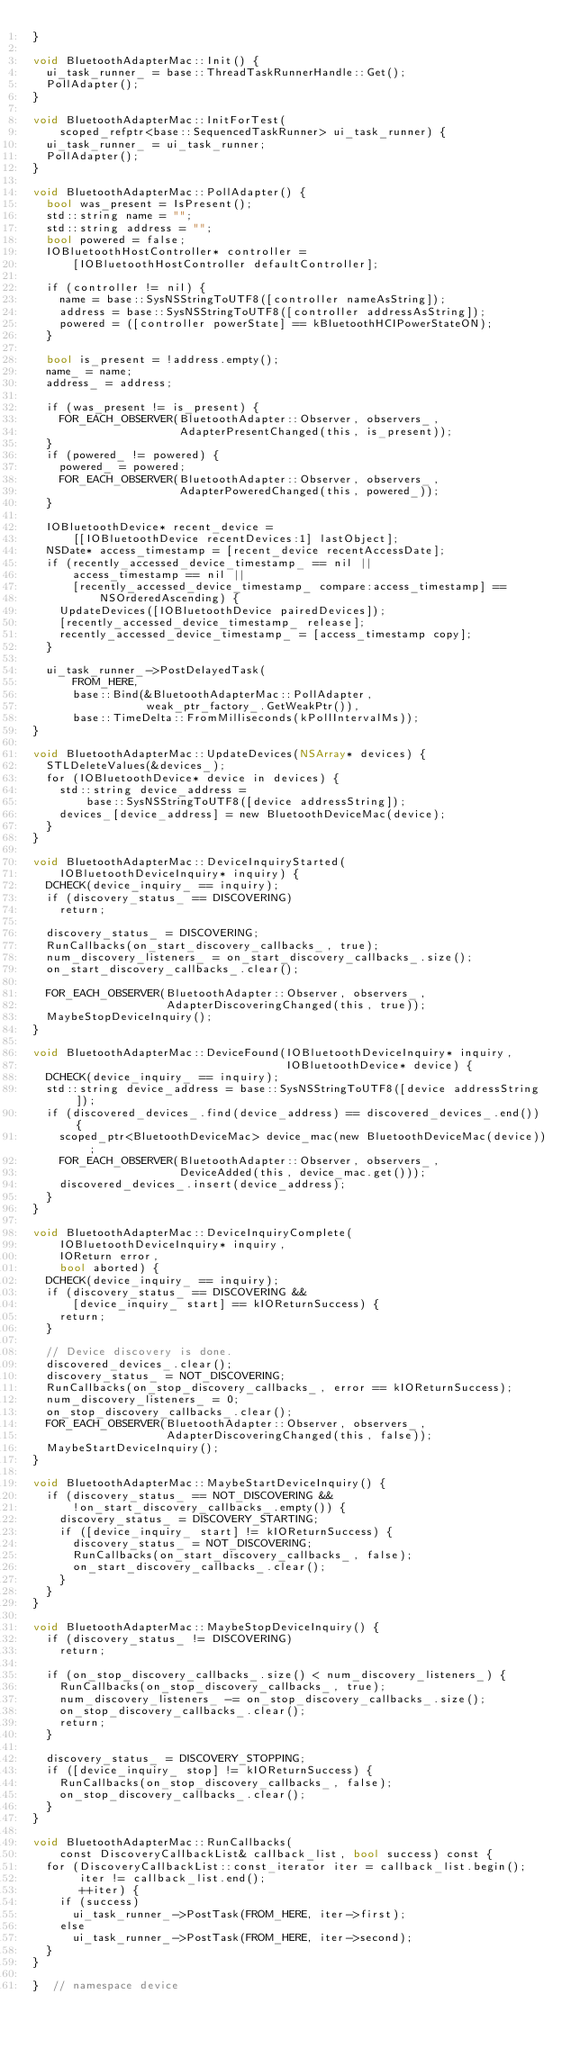<code> <loc_0><loc_0><loc_500><loc_500><_ObjectiveC_>}

void BluetoothAdapterMac::Init() {
  ui_task_runner_ = base::ThreadTaskRunnerHandle::Get();
  PollAdapter();
}

void BluetoothAdapterMac::InitForTest(
    scoped_refptr<base::SequencedTaskRunner> ui_task_runner) {
  ui_task_runner_ = ui_task_runner;
  PollAdapter();
}

void BluetoothAdapterMac::PollAdapter() {
  bool was_present = IsPresent();
  std::string name = "";
  std::string address = "";
  bool powered = false;
  IOBluetoothHostController* controller =
      [IOBluetoothHostController defaultController];

  if (controller != nil) {
    name = base::SysNSStringToUTF8([controller nameAsString]);
    address = base::SysNSStringToUTF8([controller addressAsString]);
    powered = ([controller powerState] == kBluetoothHCIPowerStateON);
  }

  bool is_present = !address.empty();
  name_ = name;
  address_ = address;

  if (was_present != is_present) {
    FOR_EACH_OBSERVER(BluetoothAdapter::Observer, observers_,
                      AdapterPresentChanged(this, is_present));
  }
  if (powered_ != powered) {
    powered_ = powered;
    FOR_EACH_OBSERVER(BluetoothAdapter::Observer, observers_,
                      AdapterPoweredChanged(this, powered_));
  }

  IOBluetoothDevice* recent_device =
      [[IOBluetoothDevice recentDevices:1] lastObject];
  NSDate* access_timestamp = [recent_device recentAccessDate];
  if (recently_accessed_device_timestamp_ == nil ||
      access_timestamp == nil ||
      [recently_accessed_device_timestamp_ compare:access_timestamp] ==
          NSOrderedAscending) {
    UpdateDevices([IOBluetoothDevice pairedDevices]);
    [recently_accessed_device_timestamp_ release];
    recently_accessed_device_timestamp_ = [access_timestamp copy];
  }

  ui_task_runner_->PostDelayedTask(
      FROM_HERE,
      base::Bind(&BluetoothAdapterMac::PollAdapter,
                 weak_ptr_factory_.GetWeakPtr()),
      base::TimeDelta::FromMilliseconds(kPollIntervalMs));
}

void BluetoothAdapterMac::UpdateDevices(NSArray* devices) {
  STLDeleteValues(&devices_);
  for (IOBluetoothDevice* device in devices) {
    std::string device_address =
        base::SysNSStringToUTF8([device addressString]);
    devices_[device_address] = new BluetoothDeviceMac(device);
  }
}

void BluetoothAdapterMac::DeviceInquiryStarted(
    IOBluetoothDeviceInquiry* inquiry) {
  DCHECK(device_inquiry_ == inquiry);
  if (discovery_status_ == DISCOVERING)
    return;

  discovery_status_ = DISCOVERING;
  RunCallbacks(on_start_discovery_callbacks_, true);
  num_discovery_listeners_ = on_start_discovery_callbacks_.size();
  on_start_discovery_callbacks_.clear();

  FOR_EACH_OBSERVER(BluetoothAdapter::Observer, observers_,
                    AdapterDiscoveringChanged(this, true));
  MaybeStopDeviceInquiry();
}

void BluetoothAdapterMac::DeviceFound(IOBluetoothDeviceInquiry* inquiry,
                                      IOBluetoothDevice* device) {
  DCHECK(device_inquiry_ == inquiry);
  std::string device_address = base::SysNSStringToUTF8([device addressString]);
  if (discovered_devices_.find(device_address) == discovered_devices_.end()) {
    scoped_ptr<BluetoothDeviceMac> device_mac(new BluetoothDeviceMac(device));
    FOR_EACH_OBSERVER(BluetoothAdapter::Observer, observers_,
                      DeviceAdded(this, device_mac.get()));
    discovered_devices_.insert(device_address);
  }
}

void BluetoothAdapterMac::DeviceInquiryComplete(
    IOBluetoothDeviceInquiry* inquiry,
    IOReturn error,
    bool aborted) {
  DCHECK(device_inquiry_ == inquiry);
  if (discovery_status_ == DISCOVERING &&
      [device_inquiry_ start] == kIOReturnSuccess) {
    return;
  }

  // Device discovery is done.
  discovered_devices_.clear();
  discovery_status_ = NOT_DISCOVERING;
  RunCallbacks(on_stop_discovery_callbacks_, error == kIOReturnSuccess);
  num_discovery_listeners_ = 0;
  on_stop_discovery_callbacks_.clear();
  FOR_EACH_OBSERVER(BluetoothAdapter::Observer, observers_,
                    AdapterDiscoveringChanged(this, false));
  MaybeStartDeviceInquiry();
}

void BluetoothAdapterMac::MaybeStartDeviceInquiry() {
  if (discovery_status_ == NOT_DISCOVERING &&
      !on_start_discovery_callbacks_.empty()) {
    discovery_status_ = DISCOVERY_STARTING;
    if ([device_inquiry_ start] != kIOReturnSuccess) {
      discovery_status_ = NOT_DISCOVERING;
      RunCallbacks(on_start_discovery_callbacks_, false);
      on_start_discovery_callbacks_.clear();
    }
  }
}

void BluetoothAdapterMac::MaybeStopDeviceInquiry() {
  if (discovery_status_ != DISCOVERING)
    return;

  if (on_stop_discovery_callbacks_.size() < num_discovery_listeners_) {
    RunCallbacks(on_stop_discovery_callbacks_, true);
    num_discovery_listeners_ -= on_stop_discovery_callbacks_.size();
    on_stop_discovery_callbacks_.clear();
    return;
  }

  discovery_status_ = DISCOVERY_STOPPING;
  if ([device_inquiry_ stop] != kIOReturnSuccess) {
    RunCallbacks(on_stop_discovery_callbacks_, false);
    on_stop_discovery_callbacks_.clear();
  }
}

void BluetoothAdapterMac::RunCallbacks(
    const DiscoveryCallbackList& callback_list, bool success) const {
  for (DiscoveryCallbackList::const_iterator iter = callback_list.begin();
       iter != callback_list.end();
       ++iter) {
    if (success)
      ui_task_runner_->PostTask(FROM_HERE, iter->first);
    else
      ui_task_runner_->PostTask(FROM_HERE, iter->second);
  }
}

}  // namespace device
</code> 